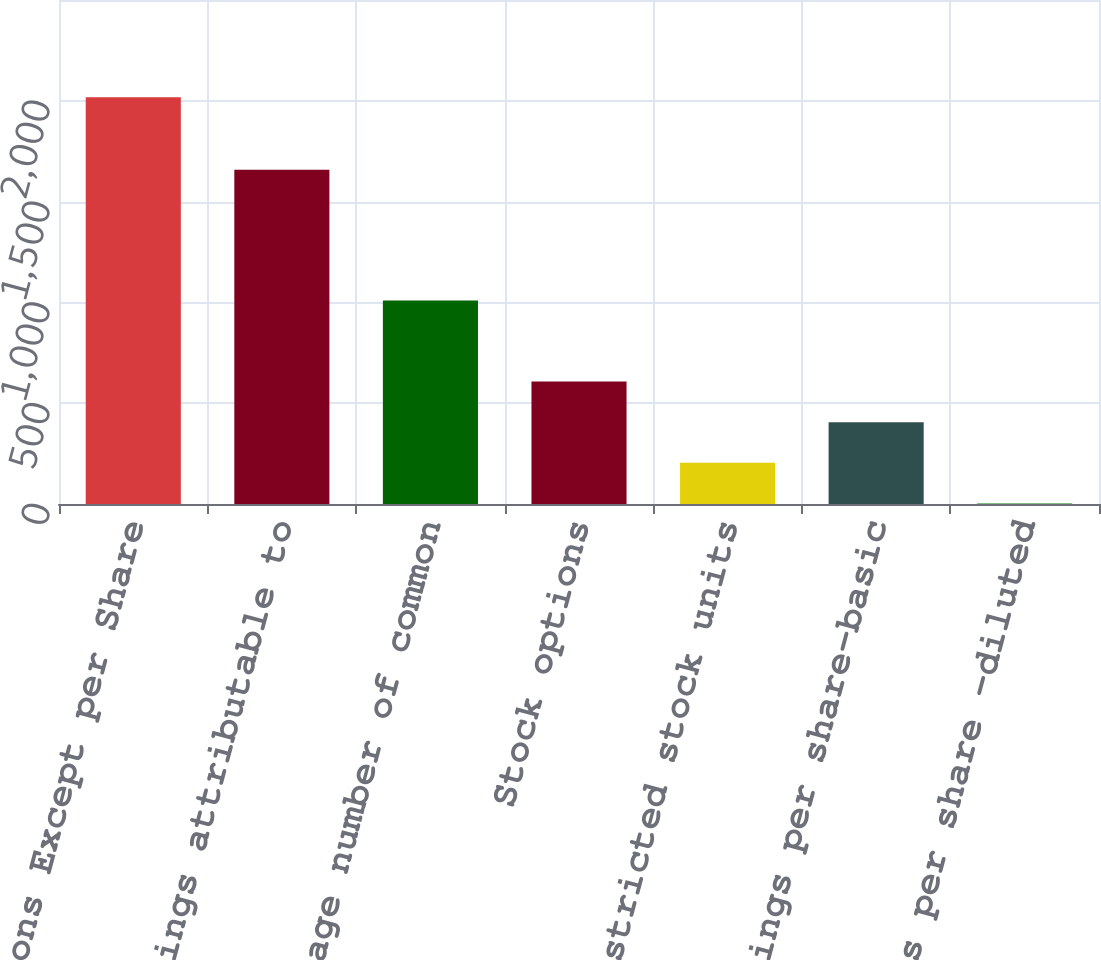<chart> <loc_0><loc_0><loc_500><loc_500><bar_chart><fcel>In Millions Except per Share<fcel>Net earnings attributable to<fcel>Average number of common<fcel>Stock options<fcel>Restricted stock units<fcel>Earnings per share-basic<fcel>Earnings per share -diluted<nl><fcel>2017<fcel>1657.5<fcel>1009.87<fcel>607.03<fcel>204.19<fcel>405.61<fcel>2.77<nl></chart> 